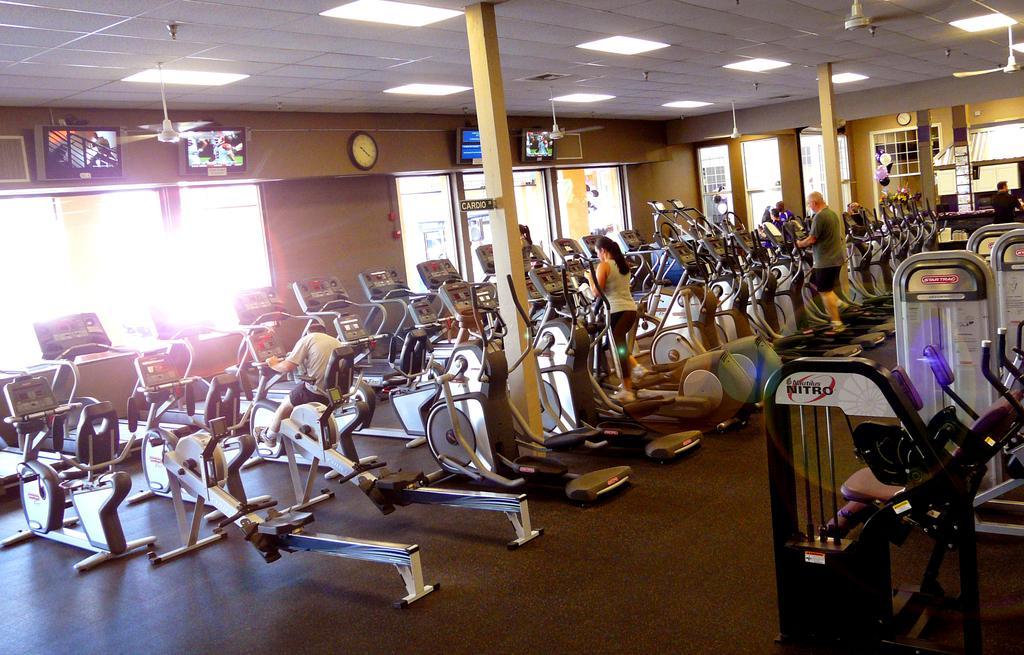Can you describe this image briefly? In this image we can see exercise machines. Also there are few people. And there are pillars. On the ceiling there are fans and lights. In the back there are windows. On the wall there are screens and clocks. Also there are few other items. 